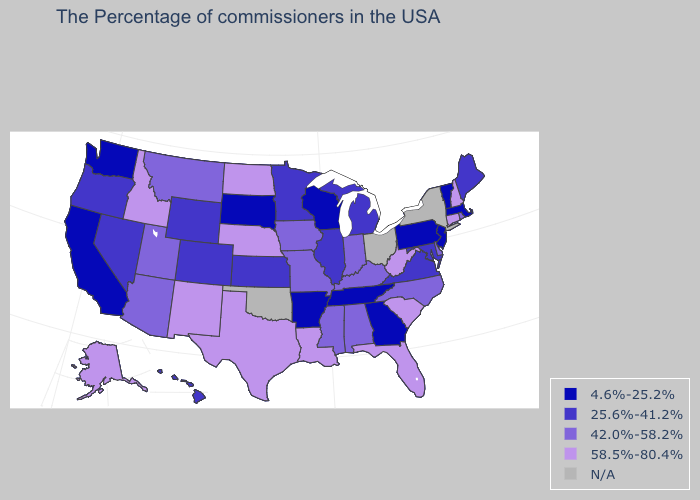Name the states that have a value in the range 4.6%-25.2%?
Write a very short answer. Massachusetts, Vermont, New Jersey, Pennsylvania, Georgia, Tennessee, Wisconsin, Arkansas, South Dakota, California, Washington. Which states have the highest value in the USA?
Write a very short answer. New Hampshire, Connecticut, South Carolina, West Virginia, Florida, Louisiana, Nebraska, Texas, North Dakota, New Mexico, Idaho, Alaska. What is the value of Nebraska?
Be succinct. 58.5%-80.4%. What is the highest value in the MidWest ?
Quick response, please. 58.5%-80.4%. What is the highest value in the USA?
Answer briefly. 58.5%-80.4%. What is the lowest value in states that border California?
Keep it brief. 25.6%-41.2%. Does California have the highest value in the West?
Answer briefly. No. Name the states that have a value in the range 25.6%-41.2%?
Be succinct. Maine, Maryland, Virginia, Michigan, Illinois, Minnesota, Kansas, Wyoming, Colorado, Nevada, Oregon, Hawaii. What is the lowest value in the USA?
Be succinct. 4.6%-25.2%. What is the lowest value in the USA?
Concise answer only. 4.6%-25.2%. What is the value of Wyoming?
Be succinct. 25.6%-41.2%. What is the highest value in the West ?
Concise answer only. 58.5%-80.4%. Name the states that have a value in the range 25.6%-41.2%?
Answer briefly. Maine, Maryland, Virginia, Michigan, Illinois, Minnesota, Kansas, Wyoming, Colorado, Nevada, Oregon, Hawaii. 